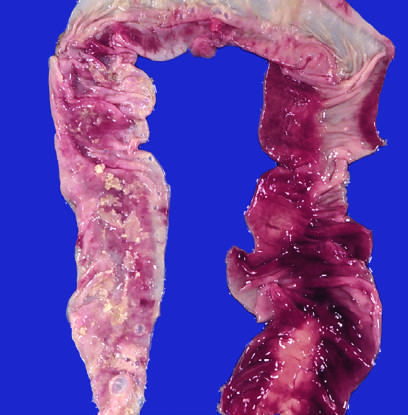what corresponds to areas of hemorrhagic infarction and transmural necrosis?
Answer the question using a single word or phrase. The congested portion of the ileum 